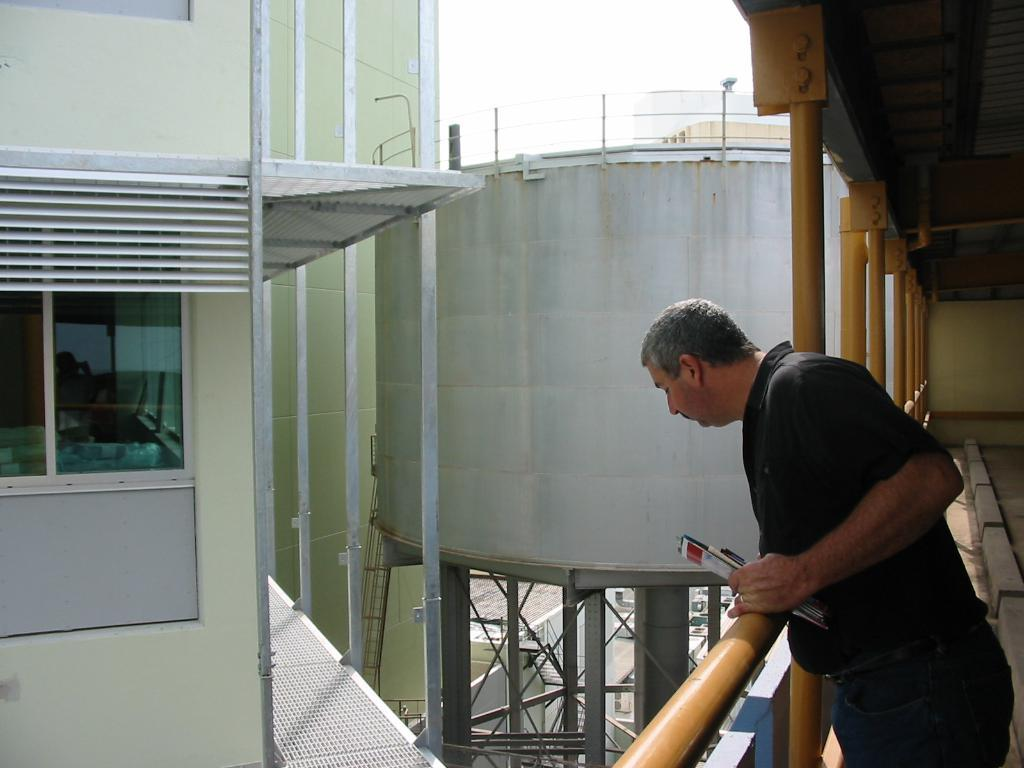What is the main subject of the image? The main subject of the image is a man. What is the man doing in the image? The man is looking downwards and holding papers in his hands. What can be seen in the background of the image? There is a building, a glass window, poles, a tanker, and the sky visible in the background of the image. What type of plants can be seen growing on the selection of mass in the image? There are no plants, selection, or mass present in the image. 